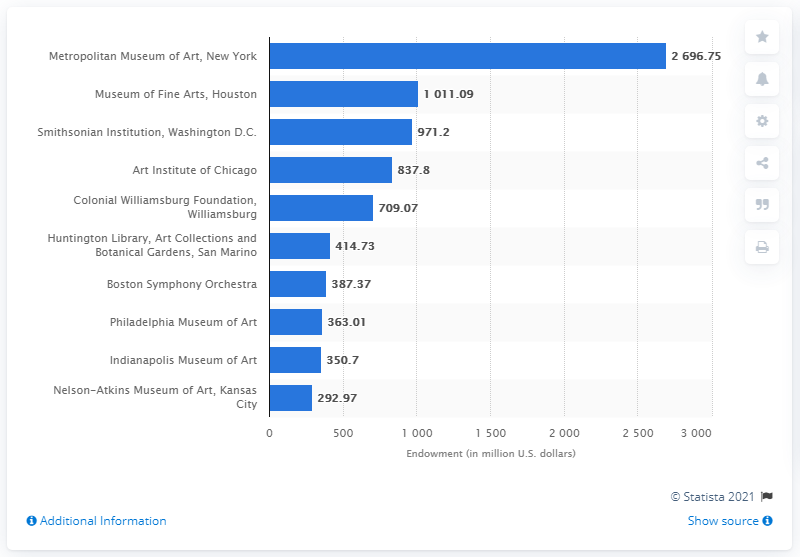Draw attention to some important aspects in this diagram. The endowment of the Metropolitan Museum of Art in 2011 was 2696.75. 